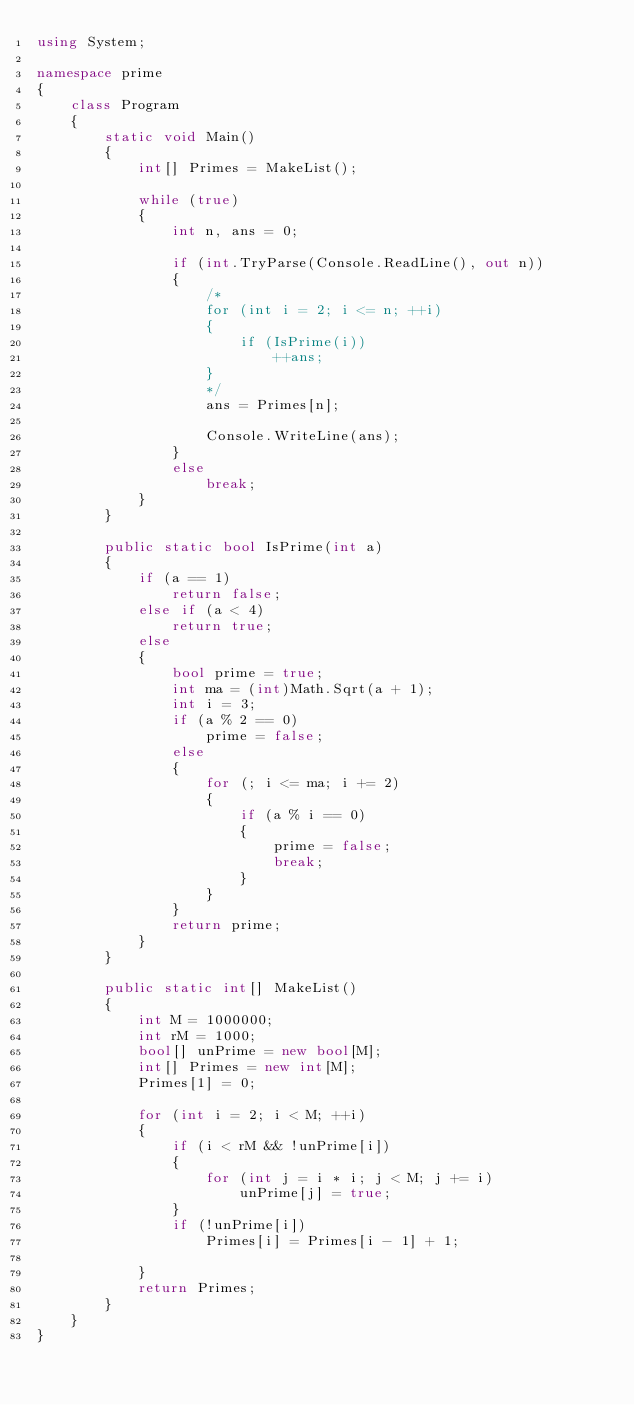Convert code to text. <code><loc_0><loc_0><loc_500><loc_500><_C#_>using System;

namespace prime
{
    class Program
    {
        static void Main()
        {
            int[] Primes = MakeList();

            while (true)
            {
                int n, ans = 0;

                if (int.TryParse(Console.ReadLine(), out n))
                {
                    /*
                    for (int i = 2; i <= n; ++i)
                    {
                        if (IsPrime(i))
                            ++ans;
                    }
                    */
                    ans = Primes[n];

                    Console.WriteLine(ans);
                }
                else
                    break;
            }
        }

        public static bool IsPrime(int a)
        {
            if (a == 1)
                return false;
            else if (a < 4)
                return true;
            else
            {
                bool prime = true;
                int ma = (int)Math.Sqrt(a + 1);
                int i = 3;
                if (a % 2 == 0)
                    prime = false;
                else
                {
                    for (; i <= ma; i += 2)
                    {
                        if (a % i == 0)
                        {
                            prime = false;
                            break;
                        }
                    }
                }
                return prime;
            }
        }

        public static int[] MakeList() 
        {
            int M = 1000000;
            int rM = 1000;
            bool[] unPrime = new bool[M];
            int[] Primes = new int[M];
            Primes[1] = 0;

            for (int i = 2; i < M; ++i) 
            {
                if (i < rM && !unPrime[i]) 
                {
                    for (int j = i * i; j < M; j += i)
                        unPrime[j] = true; 
                }
                if (!unPrime[i])
                    Primes[i] = Primes[i - 1] + 1;

            }
            return Primes;
        }
    }
}</code> 